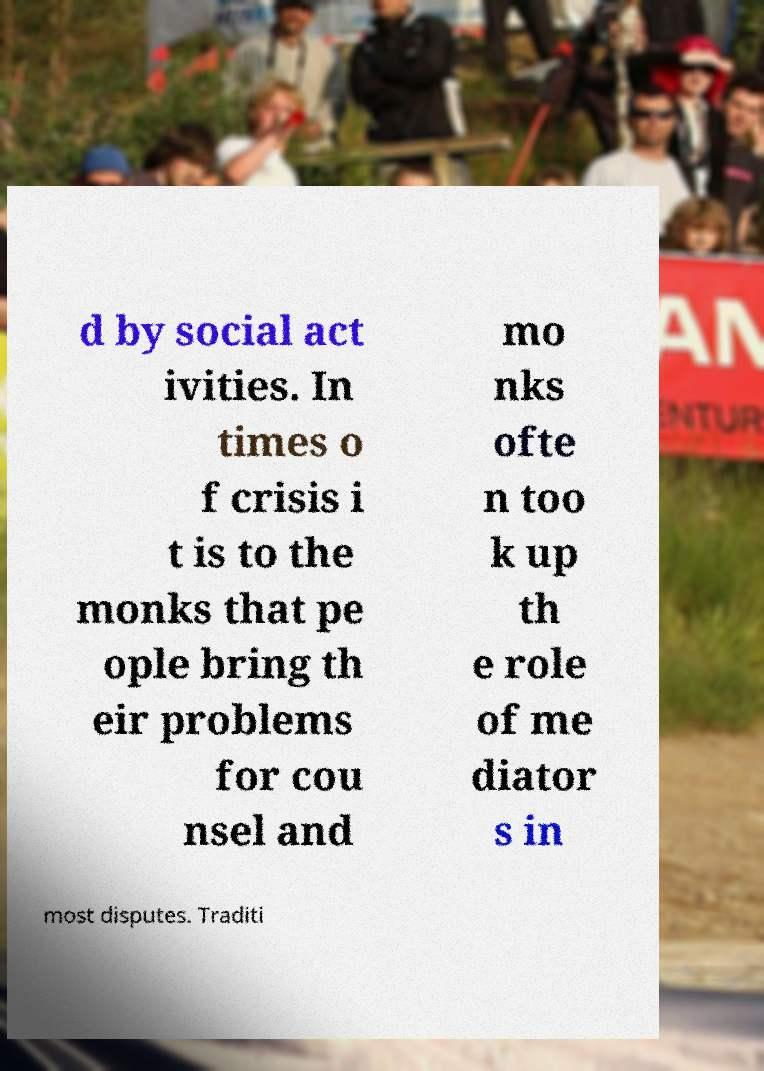I need the written content from this picture converted into text. Can you do that? d by social act ivities. In times o f crisis i t is to the monks that pe ople bring th eir problems for cou nsel and mo nks ofte n too k up th e role of me diator s in most disputes. Traditi 